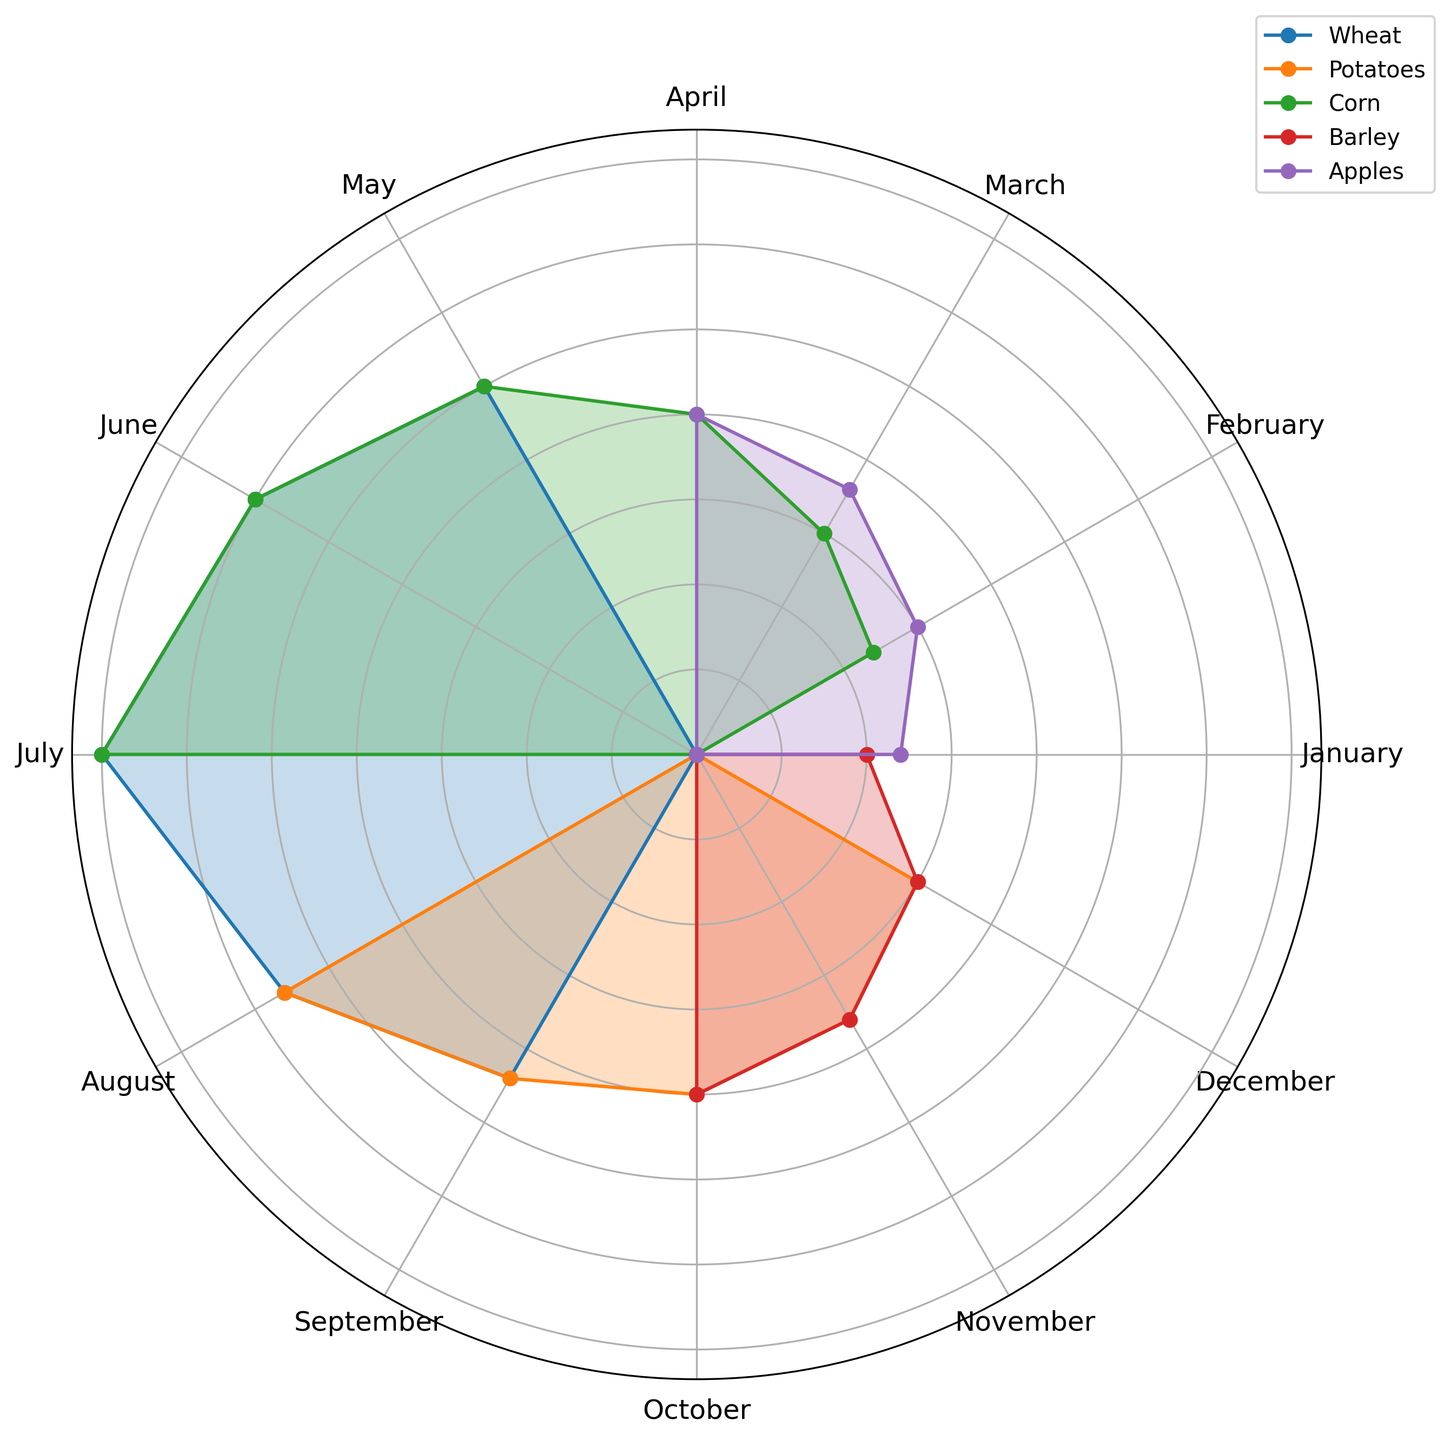Which month has the highest quantity of Apples harvested? Look at the plot and find the section referred to Apples. The highest point in the Apples section is in April.
Answer: April Which agricultural product has the highest single month's harvest throughout the year? Find the peak values for each product. Corn in July reaches the highest value with 35 tons.
Answer: Corn How many total tons of Barley are harvested in the year? Add the values of Barley across all months: 20 (Oct) + 18 (Nov) + 15 (Dec) + 10 (Jan) = 63 tons.
Answer: 63 Which product has the most consistent harvest quantity throughout the year? Observe the variance in the plot. Potatoes have relatively stable values compared to others.
Answer: Potatoes In which month does the wheat harvest peak? In the Wheat section of the plot, identify the highest point which is in July.
Answer: July Is the barley harvest higher in November or January? Compare the Barley lengths/radii for November and January. November's is longer (18 tons vs. 10 tons).
Answer: November During which month are the combined quantities of agricultural products the highest? Sum values of each month across all products and compare. July has the highest combined quantity with Wheat and Corn both at 35 tons.
Answer: July What is the average quantity of Wheat harvested from May to August? Sum Wheat harvests from May (25), June (30), July (35), and August (28), then divide by 4. Total = (25 + 30 + 35 + 28) / 4 = 29.5 tons.
Answer: 29.5 How does the corn harvest in April compare to the wheat harvest in the same month? Find both values for April. Corn is 20 tons, Wheat is not harvested in April, so Corn is higher.
Answer: Corn Which agricultural product has the lowest quantity in a single month and what is the quantity? Identify the minima for each product. Barley in January has the lowest value at 10 tons.
Answer: Barley, 10 tons 